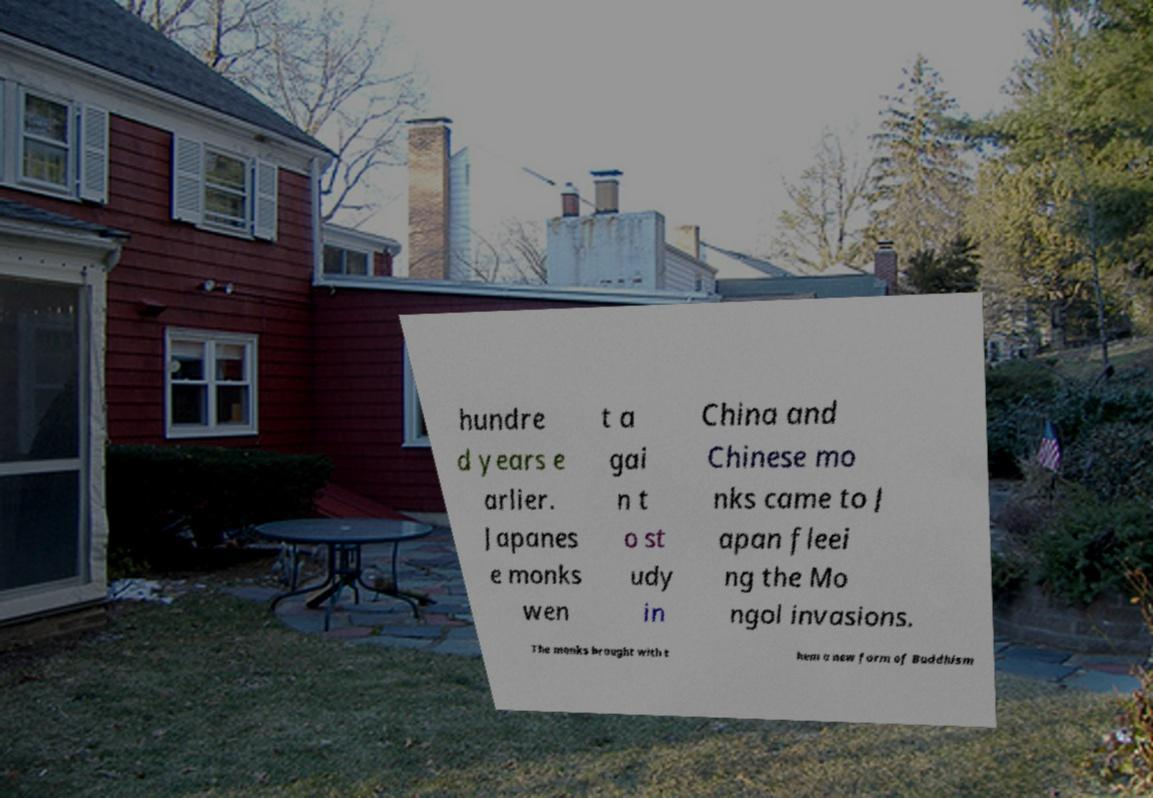Please read and relay the text visible in this image. What does it say? hundre d years e arlier. Japanes e monks wen t a gai n t o st udy in China and Chinese mo nks came to J apan fleei ng the Mo ngol invasions. The monks brought with t hem a new form of Buddhism 